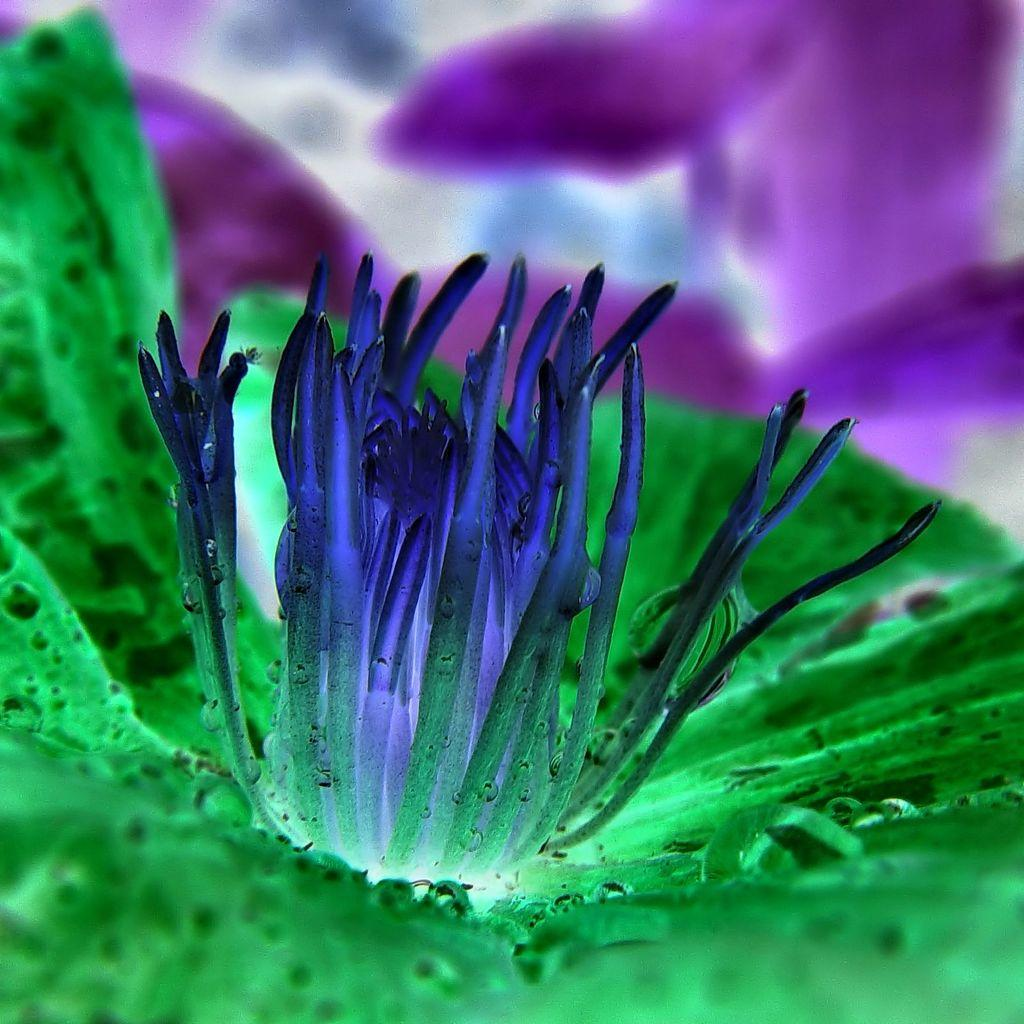What is located at the bottom of the image? There is a flower at the bottom of the image. Can you describe the background of the image? The background of the image is not clear. What can be seen in the background of the image? There are objects in the background of the image. Where is the sheep sitting on the throne in the image? There is no sheep or throne present in the image. What type of branch can be seen growing from the flower in the image? There is no branch growing from the flower in the image. 